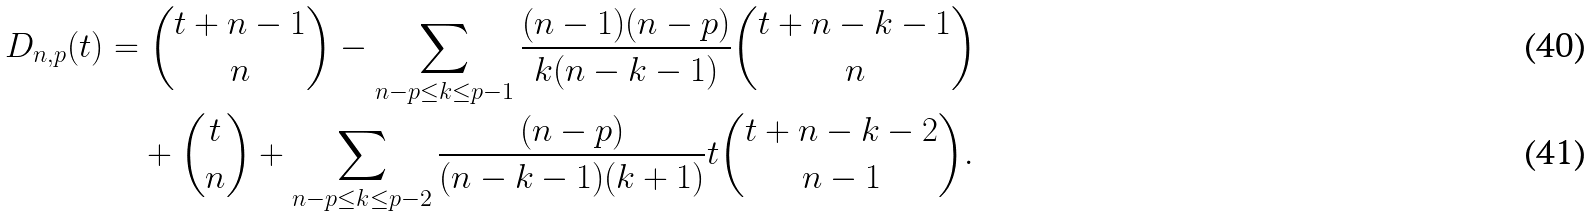Convert formula to latex. <formula><loc_0><loc_0><loc_500><loc_500>D _ { n , p } ( t ) & = \binom { t + n - 1 } { n } - \sum _ { n - p \leq k \leq p - 1 } \frac { ( n - 1 ) ( n - p ) } { k ( n - k - 1 ) } \binom { t + n - k - 1 } { n } \\ & \quad + \binom { t } { n } + \sum _ { n - p \leq k \leq p - 2 } \frac { ( n - p ) } { ( n - k - 1 ) ( k + 1 ) } t \binom { t + n - k - 2 } { n - 1 } .</formula> 